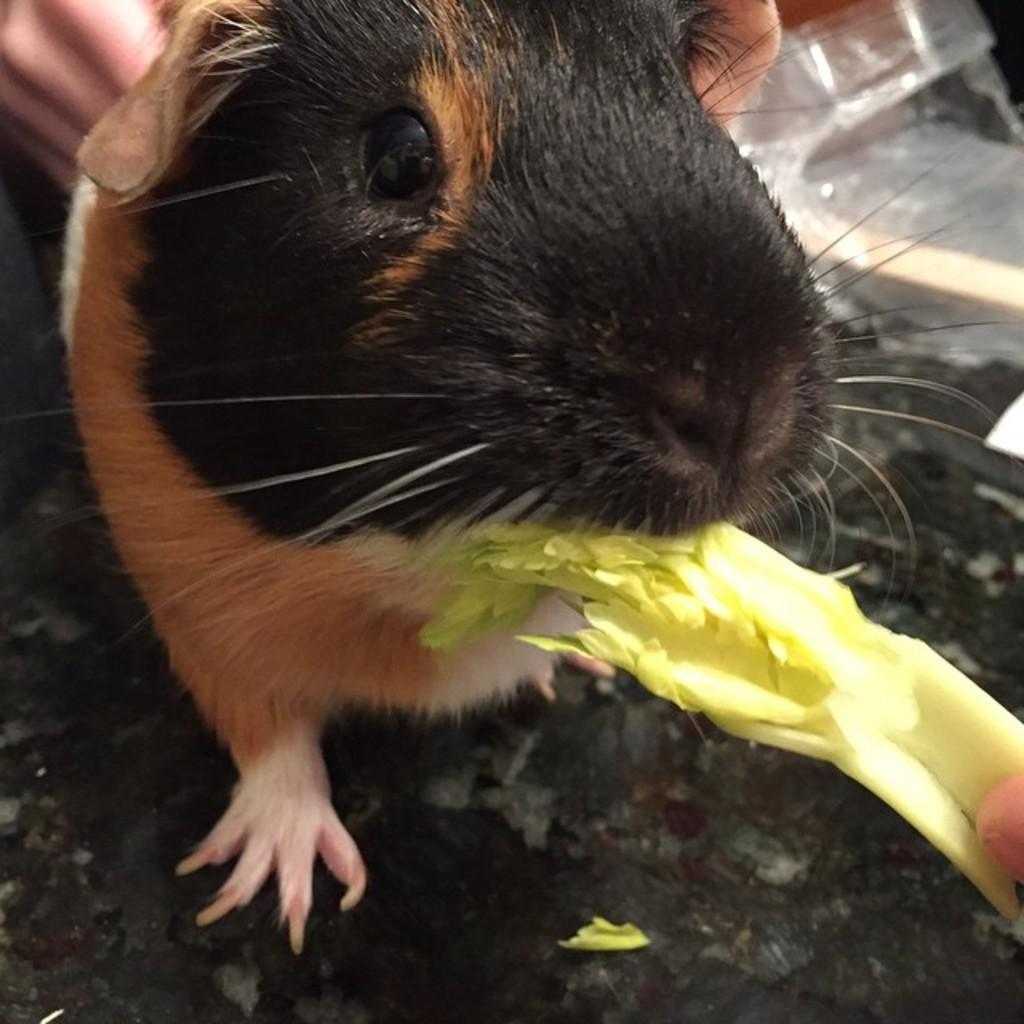In one or two sentences, can you explain what this image depicts? This picture shows a rat. It is black brown and white in color and it's eating some veggies and we see a human hand. 